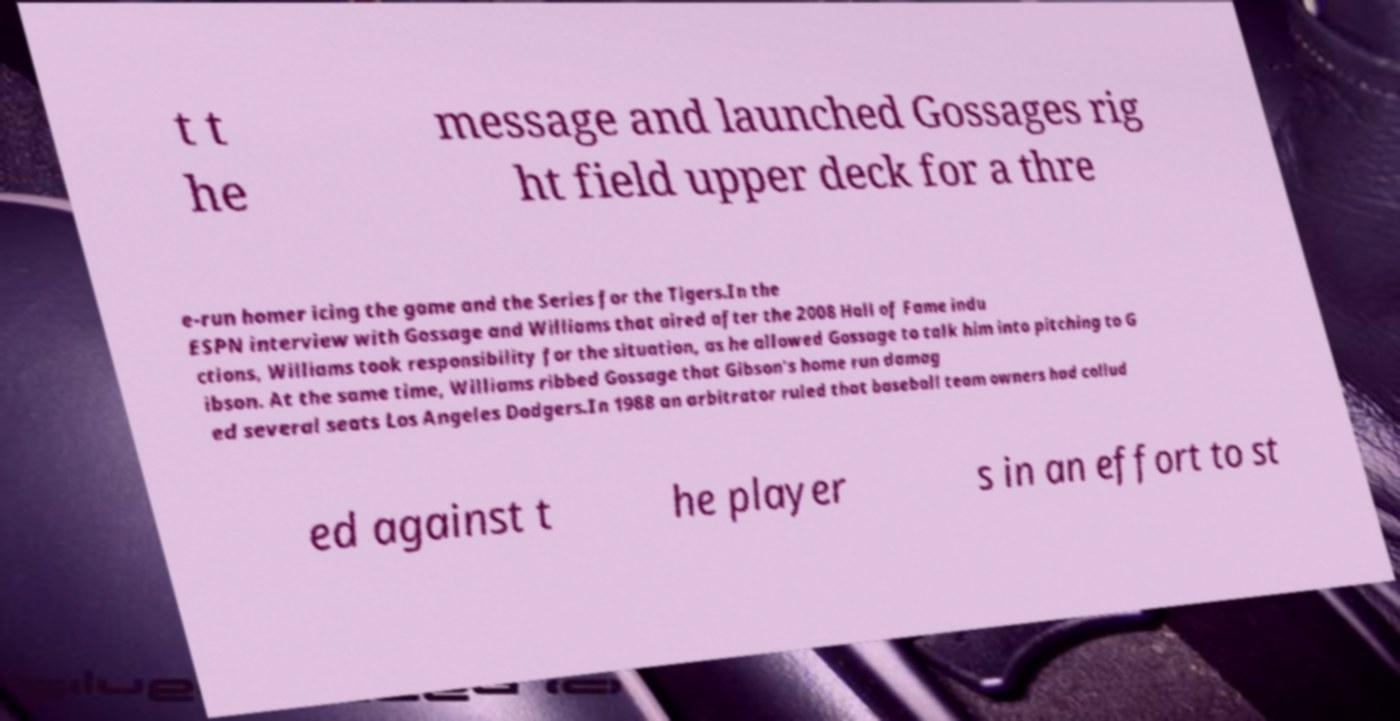For documentation purposes, I need the text within this image transcribed. Could you provide that? t t he message and launched Gossages rig ht field upper deck for a thre e-run homer icing the game and the Series for the Tigers.In the ESPN interview with Gossage and Williams that aired after the 2008 Hall of Fame indu ctions, Williams took responsibility for the situation, as he allowed Gossage to talk him into pitching to G ibson. At the same time, Williams ribbed Gossage that Gibson's home run damag ed several seats Los Angeles Dodgers.In 1988 an arbitrator ruled that baseball team owners had collud ed against t he player s in an effort to st 